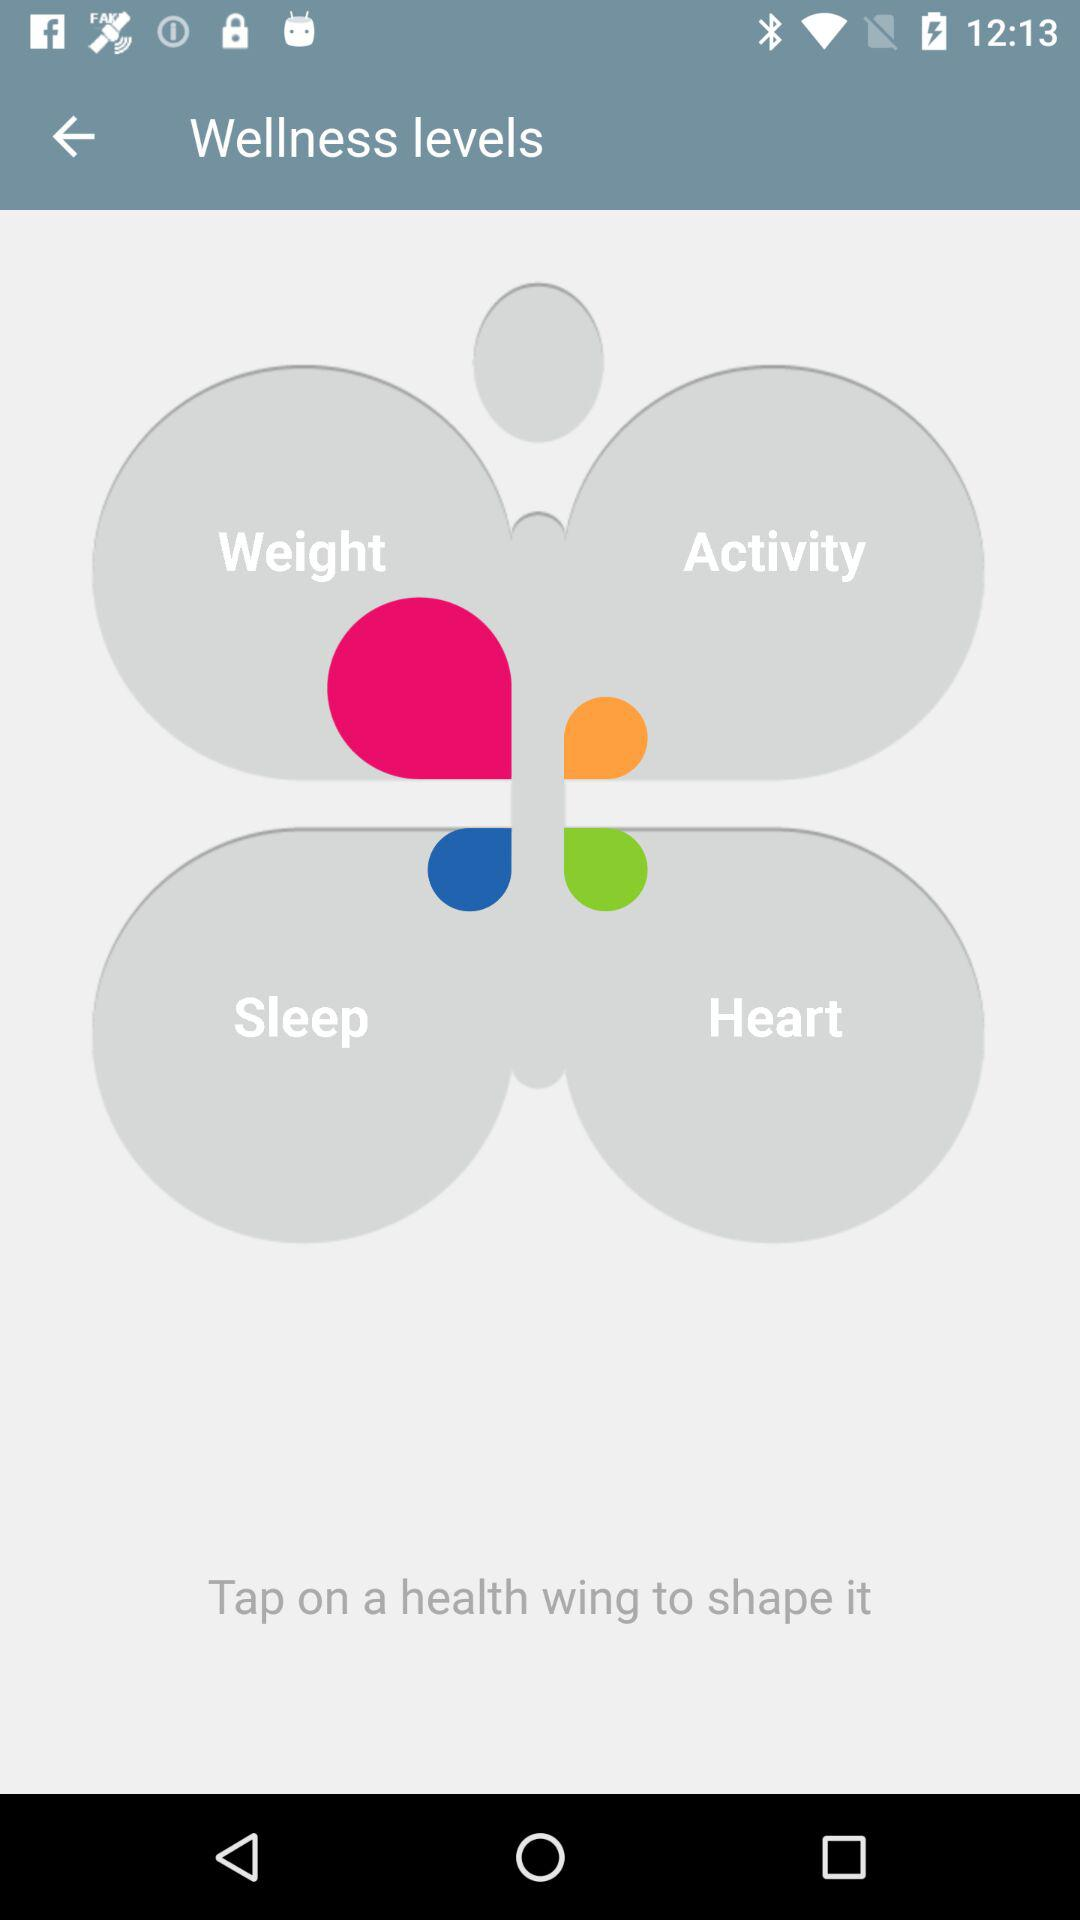How many wellness levels are available?
Answer the question using a single word or phrase. 4 